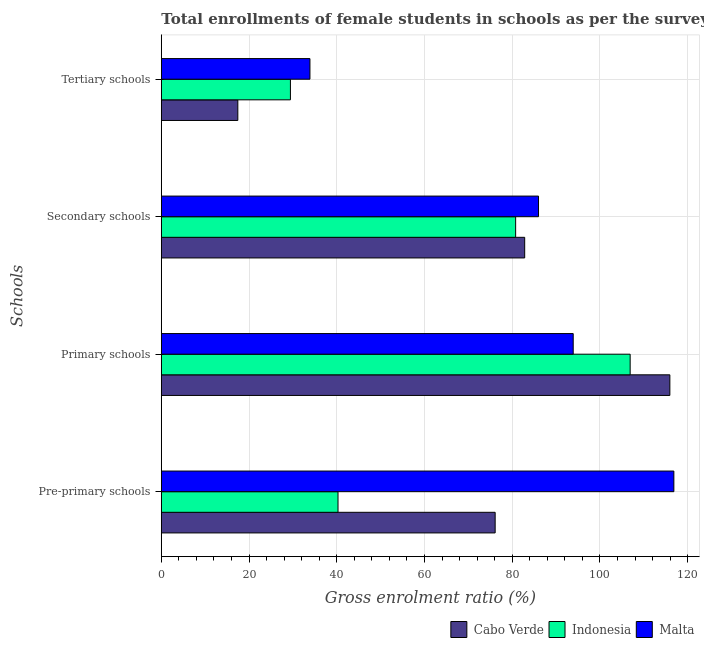How many groups of bars are there?
Provide a succinct answer. 4. Are the number of bars per tick equal to the number of legend labels?
Give a very brief answer. Yes. How many bars are there on the 3rd tick from the top?
Your answer should be compact. 3. What is the label of the 3rd group of bars from the top?
Provide a short and direct response. Primary schools. What is the gross enrolment ratio(female) in secondary schools in Cabo Verde?
Provide a succinct answer. 82.85. Across all countries, what is the maximum gross enrolment ratio(female) in secondary schools?
Offer a very short reply. 86. Across all countries, what is the minimum gross enrolment ratio(female) in secondary schools?
Your answer should be very brief. 80.79. In which country was the gross enrolment ratio(female) in primary schools maximum?
Ensure brevity in your answer.  Cabo Verde. In which country was the gross enrolment ratio(female) in tertiary schools minimum?
Provide a succinct answer. Cabo Verde. What is the total gross enrolment ratio(female) in tertiary schools in the graph?
Offer a very short reply. 80.76. What is the difference between the gross enrolment ratio(female) in tertiary schools in Cabo Verde and that in Indonesia?
Give a very brief answer. -11.99. What is the difference between the gross enrolment ratio(female) in tertiary schools in Malta and the gross enrolment ratio(female) in pre-primary schools in Indonesia?
Your answer should be compact. -6.4. What is the average gross enrolment ratio(female) in tertiary schools per country?
Ensure brevity in your answer.  26.92. What is the difference between the gross enrolment ratio(female) in primary schools and gross enrolment ratio(female) in pre-primary schools in Malta?
Your answer should be very brief. -22.95. In how many countries, is the gross enrolment ratio(female) in secondary schools greater than 112 %?
Give a very brief answer. 0. What is the ratio of the gross enrolment ratio(female) in tertiary schools in Indonesia to that in Cabo Verde?
Ensure brevity in your answer.  1.69. What is the difference between the highest and the second highest gross enrolment ratio(female) in pre-primary schools?
Your answer should be compact. 40.74. What is the difference between the highest and the lowest gross enrolment ratio(female) in primary schools?
Provide a short and direct response. 22.04. Is the sum of the gross enrolment ratio(female) in primary schools in Indonesia and Malta greater than the maximum gross enrolment ratio(female) in secondary schools across all countries?
Provide a short and direct response. Yes. Is it the case that in every country, the sum of the gross enrolment ratio(female) in secondary schools and gross enrolment ratio(female) in tertiary schools is greater than the sum of gross enrolment ratio(female) in pre-primary schools and gross enrolment ratio(female) in primary schools?
Keep it short and to the point. No. What does the 1st bar from the top in Secondary schools represents?
Give a very brief answer. Malta. What does the 1st bar from the bottom in Primary schools represents?
Your answer should be compact. Cabo Verde. Is it the case that in every country, the sum of the gross enrolment ratio(female) in pre-primary schools and gross enrolment ratio(female) in primary schools is greater than the gross enrolment ratio(female) in secondary schools?
Your answer should be compact. Yes. How many countries are there in the graph?
Your answer should be compact. 3. Are the values on the major ticks of X-axis written in scientific E-notation?
Your answer should be very brief. No. Does the graph contain grids?
Make the answer very short. Yes. How many legend labels are there?
Ensure brevity in your answer.  3. What is the title of the graph?
Offer a very short reply. Total enrollments of female students in schools as per the survey of 2011 conducted in different countries. Does "Hungary" appear as one of the legend labels in the graph?
Your answer should be very brief. No. What is the label or title of the Y-axis?
Provide a succinct answer. Schools. What is the Gross enrolment ratio (%) of Cabo Verde in Pre-primary schools?
Make the answer very short. 76.12. What is the Gross enrolment ratio (%) in Indonesia in Pre-primary schools?
Your response must be concise. 40.29. What is the Gross enrolment ratio (%) of Malta in Pre-primary schools?
Keep it short and to the point. 116.86. What is the Gross enrolment ratio (%) in Cabo Verde in Primary schools?
Offer a terse response. 115.94. What is the Gross enrolment ratio (%) in Indonesia in Primary schools?
Provide a succinct answer. 106.89. What is the Gross enrolment ratio (%) in Malta in Primary schools?
Offer a very short reply. 93.91. What is the Gross enrolment ratio (%) in Cabo Verde in Secondary schools?
Provide a succinct answer. 82.85. What is the Gross enrolment ratio (%) of Indonesia in Secondary schools?
Keep it short and to the point. 80.79. What is the Gross enrolment ratio (%) in Malta in Secondary schools?
Provide a succinct answer. 86. What is the Gross enrolment ratio (%) in Cabo Verde in Tertiary schools?
Make the answer very short. 17.44. What is the Gross enrolment ratio (%) of Indonesia in Tertiary schools?
Keep it short and to the point. 29.43. What is the Gross enrolment ratio (%) of Malta in Tertiary schools?
Ensure brevity in your answer.  33.88. Across all Schools, what is the maximum Gross enrolment ratio (%) of Cabo Verde?
Offer a terse response. 115.94. Across all Schools, what is the maximum Gross enrolment ratio (%) in Indonesia?
Offer a terse response. 106.89. Across all Schools, what is the maximum Gross enrolment ratio (%) in Malta?
Your response must be concise. 116.86. Across all Schools, what is the minimum Gross enrolment ratio (%) in Cabo Verde?
Give a very brief answer. 17.44. Across all Schools, what is the minimum Gross enrolment ratio (%) of Indonesia?
Your response must be concise. 29.43. Across all Schools, what is the minimum Gross enrolment ratio (%) of Malta?
Your answer should be compact. 33.88. What is the total Gross enrolment ratio (%) in Cabo Verde in the graph?
Offer a terse response. 292.35. What is the total Gross enrolment ratio (%) in Indonesia in the graph?
Keep it short and to the point. 257.4. What is the total Gross enrolment ratio (%) of Malta in the graph?
Offer a very short reply. 330.65. What is the difference between the Gross enrolment ratio (%) in Cabo Verde in Pre-primary schools and that in Primary schools?
Provide a succinct answer. -39.83. What is the difference between the Gross enrolment ratio (%) in Indonesia in Pre-primary schools and that in Primary schools?
Provide a short and direct response. -66.6. What is the difference between the Gross enrolment ratio (%) of Malta in Pre-primary schools and that in Primary schools?
Offer a very short reply. 22.95. What is the difference between the Gross enrolment ratio (%) in Cabo Verde in Pre-primary schools and that in Secondary schools?
Ensure brevity in your answer.  -6.73. What is the difference between the Gross enrolment ratio (%) in Indonesia in Pre-primary schools and that in Secondary schools?
Provide a short and direct response. -40.5. What is the difference between the Gross enrolment ratio (%) in Malta in Pre-primary schools and that in Secondary schools?
Make the answer very short. 30.86. What is the difference between the Gross enrolment ratio (%) of Cabo Verde in Pre-primary schools and that in Tertiary schools?
Ensure brevity in your answer.  58.67. What is the difference between the Gross enrolment ratio (%) of Indonesia in Pre-primary schools and that in Tertiary schools?
Your answer should be compact. 10.85. What is the difference between the Gross enrolment ratio (%) in Malta in Pre-primary schools and that in Tertiary schools?
Offer a very short reply. 82.97. What is the difference between the Gross enrolment ratio (%) in Cabo Verde in Primary schools and that in Secondary schools?
Your answer should be compact. 33.1. What is the difference between the Gross enrolment ratio (%) of Indonesia in Primary schools and that in Secondary schools?
Ensure brevity in your answer.  26.11. What is the difference between the Gross enrolment ratio (%) in Malta in Primary schools and that in Secondary schools?
Ensure brevity in your answer.  7.91. What is the difference between the Gross enrolment ratio (%) of Cabo Verde in Primary schools and that in Tertiary schools?
Offer a very short reply. 98.5. What is the difference between the Gross enrolment ratio (%) of Indonesia in Primary schools and that in Tertiary schools?
Offer a very short reply. 77.46. What is the difference between the Gross enrolment ratio (%) in Malta in Primary schools and that in Tertiary schools?
Ensure brevity in your answer.  60.02. What is the difference between the Gross enrolment ratio (%) in Cabo Verde in Secondary schools and that in Tertiary schools?
Make the answer very short. 65.4. What is the difference between the Gross enrolment ratio (%) of Indonesia in Secondary schools and that in Tertiary schools?
Offer a very short reply. 51.35. What is the difference between the Gross enrolment ratio (%) in Malta in Secondary schools and that in Tertiary schools?
Keep it short and to the point. 52.11. What is the difference between the Gross enrolment ratio (%) in Cabo Verde in Pre-primary schools and the Gross enrolment ratio (%) in Indonesia in Primary schools?
Make the answer very short. -30.78. What is the difference between the Gross enrolment ratio (%) of Cabo Verde in Pre-primary schools and the Gross enrolment ratio (%) of Malta in Primary schools?
Offer a terse response. -17.79. What is the difference between the Gross enrolment ratio (%) of Indonesia in Pre-primary schools and the Gross enrolment ratio (%) of Malta in Primary schools?
Make the answer very short. -53.62. What is the difference between the Gross enrolment ratio (%) in Cabo Verde in Pre-primary schools and the Gross enrolment ratio (%) in Indonesia in Secondary schools?
Your answer should be very brief. -4.67. What is the difference between the Gross enrolment ratio (%) of Cabo Verde in Pre-primary schools and the Gross enrolment ratio (%) of Malta in Secondary schools?
Your response must be concise. -9.88. What is the difference between the Gross enrolment ratio (%) in Indonesia in Pre-primary schools and the Gross enrolment ratio (%) in Malta in Secondary schools?
Offer a terse response. -45.71. What is the difference between the Gross enrolment ratio (%) in Cabo Verde in Pre-primary schools and the Gross enrolment ratio (%) in Indonesia in Tertiary schools?
Provide a short and direct response. 46.68. What is the difference between the Gross enrolment ratio (%) in Cabo Verde in Pre-primary schools and the Gross enrolment ratio (%) in Malta in Tertiary schools?
Offer a very short reply. 42.23. What is the difference between the Gross enrolment ratio (%) in Indonesia in Pre-primary schools and the Gross enrolment ratio (%) in Malta in Tertiary schools?
Keep it short and to the point. 6.4. What is the difference between the Gross enrolment ratio (%) of Cabo Verde in Primary schools and the Gross enrolment ratio (%) of Indonesia in Secondary schools?
Offer a very short reply. 35.16. What is the difference between the Gross enrolment ratio (%) of Cabo Verde in Primary schools and the Gross enrolment ratio (%) of Malta in Secondary schools?
Your answer should be very brief. 29.94. What is the difference between the Gross enrolment ratio (%) in Indonesia in Primary schools and the Gross enrolment ratio (%) in Malta in Secondary schools?
Make the answer very short. 20.89. What is the difference between the Gross enrolment ratio (%) of Cabo Verde in Primary schools and the Gross enrolment ratio (%) of Indonesia in Tertiary schools?
Ensure brevity in your answer.  86.51. What is the difference between the Gross enrolment ratio (%) in Cabo Verde in Primary schools and the Gross enrolment ratio (%) in Malta in Tertiary schools?
Your answer should be compact. 82.06. What is the difference between the Gross enrolment ratio (%) in Indonesia in Primary schools and the Gross enrolment ratio (%) in Malta in Tertiary schools?
Your answer should be very brief. 73.01. What is the difference between the Gross enrolment ratio (%) of Cabo Verde in Secondary schools and the Gross enrolment ratio (%) of Indonesia in Tertiary schools?
Offer a terse response. 53.41. What is the difference between the Gross enrolment ratio (%) of Cabo Verde in Secondary schools and the Gross enrolment ratio (%) of Malta in Tertiary schools?
Make the answer very short. 48.96. What is the difference between the Gross enrolment ratio (%) of Indonesia in Secondary schools and the Gross enrolment ratio (%) of Malta in Tertiary schools?
Provide a succinct answer. 46.9. What is the average Gross enrolment ratio (%) of Cabo Verde per Schools?
Give a very brief answer. 73.09. What is the average Gross enrolment ratio (%) of Indonesia per Schools?
Ensure brevity in your answer.  64.35. What is the average Gross enrolment ratio (%) of Malta per Schools?
Provide a succinct answer. 82.66. What is the difference between the Gross enrolment ratio (%) in Cabo Verde and Gross enrolment ratio (%) in Indonesia in Pre-primary schools?
Your response must be concise. 35.83. What is the difference between the Gross enrolment ratio (%) of Cabo Verde and Gross enrolment ratio (%) of Malta in Pre-primary schools?
Offer a very short reply. -40.74. What is the difference between the Gross enrolment ratio (%) in Indonesia and Gross enrolment ratio (%) in Malta in Pre-primary schools?
Give a very brief answer. -76.57. What is the difference between the Gross enrolment ratio (%) of Cabo Verde and Gross enrolment ratio (%) of Indonesia in Primary schools?
Ensure brevity in your answer.  9.05. What is the difference between the Gross enrolment ratio (%) in Cabo Verde and Gross enrolment ratio (%) in Malta in Primary schools?
Provide a succinct answer. 22.04. What is the difference between the Gross enrolment ratio (%) of Indonesia and Gross enrolment ratio (%) of Malta in Primary schools?
Provide a short and direct response. 12.98. What is the difference between the Gross enrolment ratio (%) in Cabo Verde and Gross enrolment ratio (%) in Indonesia in Secondary schools?
Give a very brief answer. 2.06. What is the difference between the Gross enrolment ratio (%) in Cabo Verde and Gross enrolment ratio (%) in Malta in Secondary schools?
Your response must be concise. -3.15. What is the difference between the Gross enrolment ratio (%) of Indonesia and Gross enrolment ratio (%) of Malta in Secondary schools?
Your response must be concise. -5.21. What is the difference between the Gross enrolment ratio (%) in Cabo Verde and Gross enrolment ratio (%) in Indonesia in Tertiary schools?
Your answer should be very brief. -11.99. What is the difference between the Gross enrolment ratio (%) of Cabo Verde and Gross enrolment ratio (%) of Malta in Tertiary schools?
Keep it short and to the point. -16.44. What is the difference between the Gross enrolment ratio (%) of Indonesia and Gross enrolment ratio (%) of Malta in Tertiary schools?
Provide a short and direct response. -4.45. What is the ratio of the Gross enrolment ratio (%) in Cabo Verde in Pre-primary schools to that in Primary schools?
Ensure brevity in your answer.  0.66. What is the ratio of the Gross enrolment ratio (%) in Indonesia in Pre-primary schools to that in Primary schools?
Keep it short and to the point. 0.38. What is the ratio of the Gross enrolment ratio (%) in Malta in Pre-primary schools to that in Primary schools?
Provide a short and direct response. 1.24. What is the ratio of the Gross enrolment ratio (%) of Cabo Verde in Pre-primary schools to that in Secondary schools?
Offer a very short reply. 0.92. What is the ratio of the Gross enrolment ratio (%) of Indonesia in Pre-primary schools to that in Secondary schools?
Your response must be concise. 0.5. What is the ratio of the Gross enrolment ratio (%) in Malta in Pre-primary schools to that in Secondary schools?
Your response must be concise. 1.36. What is the ratio of the Gross enrolment ratio (%) in Cabo Verde in Pre-primary schools to that in Tertiary schools?
Offer a very short reply. 4.36. What is the ratio of the Gross enrolment ratio (%) of Indonesia in Pre-primary schools to that in Tertiary schools?
Provide a succinct answer. 1.37. What is the ratio of the Gross enrolment ratio (%) of Malta in Pre-primary schools to that in Tertiary schools?
Make the answer very short. 3.45. What is the ratio of the Gross enrolment ratio (%) of Cabo Verde in Primary schools to that in Secondary schools?
Offer a terse response. 1.4. What is the ratio of the Gross enrolment ratio (%) in Indonesia in Primary schools to that in Secondary schools?
Your answer should be compact. 1.32. What is the ratio of the Gross enrolment ratio (%) of Malta in Primary schools to that in Secondary schools?
Your answer should be compact. 1.09. What is the ratio of the Gross enrolment ratio (%) of Cabo Verde in Primary schools to that in Tertiary schools?
Offer a very short reply. 6.65. What is the ratio of the Gross enrolment ratio (%) in Indonesia in Primary schools to that in Tertiary schools?
Your answer should be very brief. 3.63. What is the ratio of the Gross enrolment ratio (%) in Malta in Primary schools to that in Tertiary schools?
Make the answer very short. 2.77. What is the ratio of the Gross enrolment ratio (%) in Cabo Verde in Secondary schools to that in Tertiary schools?
Offer a terse response. 4.75. What is the ratio of the Gross enrolment ratio (%) of Indonesia in Secondary schools to that in Tertiary schools?
Ensure brevity in your answer.  2.74. What is the ratio of the Gross enrolment ratio (%) in Malta in Secondary schools to that in Tertiary schools?
Make the answer very short. 2.54. What is the difference between the highest and the second highest Gross enrolment ratio (%) in Cabo Verde?
Offer a terse response. 33.1. What is the difference between the highest and the second highest Gross enrolment ratio (%) in Indonesia?
Your response must be concise. 26.11. What is the difference between the highest and the second highest Gross enrolment ratio (%) in Malta?
Keep it short and to the point. 22.95. What is the difference between the highest and the lowest Gross enrolment ratio (%) in Cabo Verde?
Give a very brief answer. 98.5. What is the difference between the highest and the lowest Gross enrolment ratio (%) of Indonesia?
Keep it short and to the point. 77.46. What is the difference between the highest and the lowest Gross enrolment ratio (%) of Malta?
Keep it short and to the point. 82.97. 